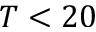Convert formula to latex. <formula><loc_0><loc_0><loc_500><loc_500>T < 2 0</formula> 